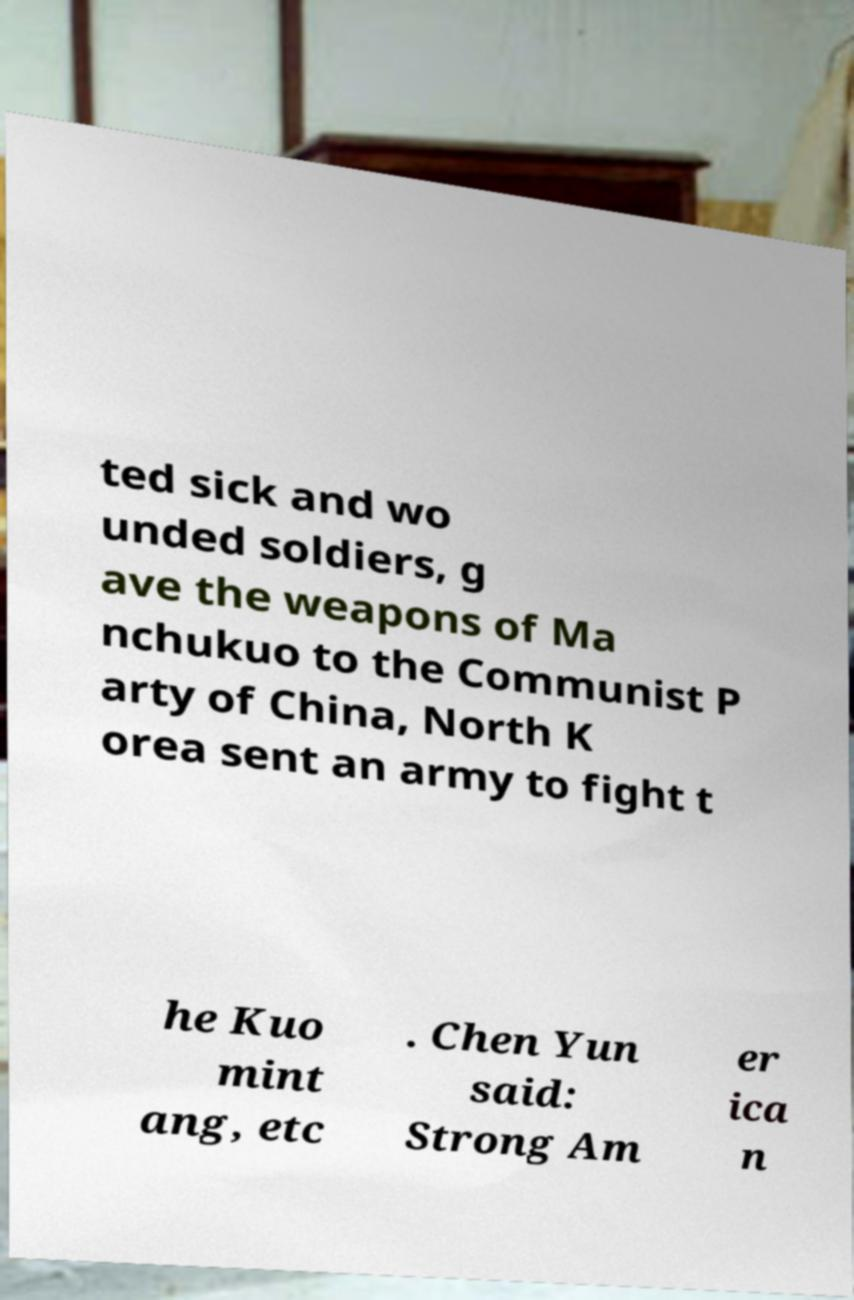Can you read and provide the text displayed in the image?This photo seems to have some interesting text. Can you extract and type it out for me? ted sick and wo unded soldiers, g ave the weapons of Ma nchukuo to the Communist P arty of China, North K orea sent an army to fight t he Kuo mint ang, etc . Chen Yun said: Strong Am er ica n 